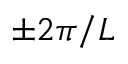Convert formula to latex. <formula><loc_0><loc_0><loc_500><loc_500>\pm 2 \pi / L</formula> 